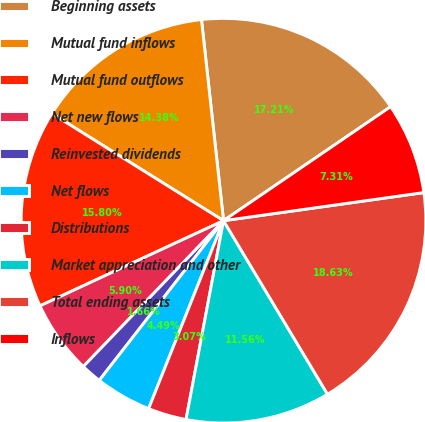Convert chart. <chart><loc_0><loc_0><loc_500><loc_500><pie_chart><fcel>Beginning assets<fcel>Mutual fund inflows<fcel>Mutual fund outflows<fcel>Net new flows<fcel>Reinvested dividends<fcel>Net flows<fcel>Distributions<fcel>Market appreciation and other<fcel>Total ending assets<fcel>Inflows<nl><fcel>17.21%<fcel>14.38%<fcel>15.8%<fcel>5.9%<fcel>1.66%<fcel>4.49%<fcel>3.07%<fcel>11.56%<fcel>18.63%<fcel>7.31%<nl></chart> 